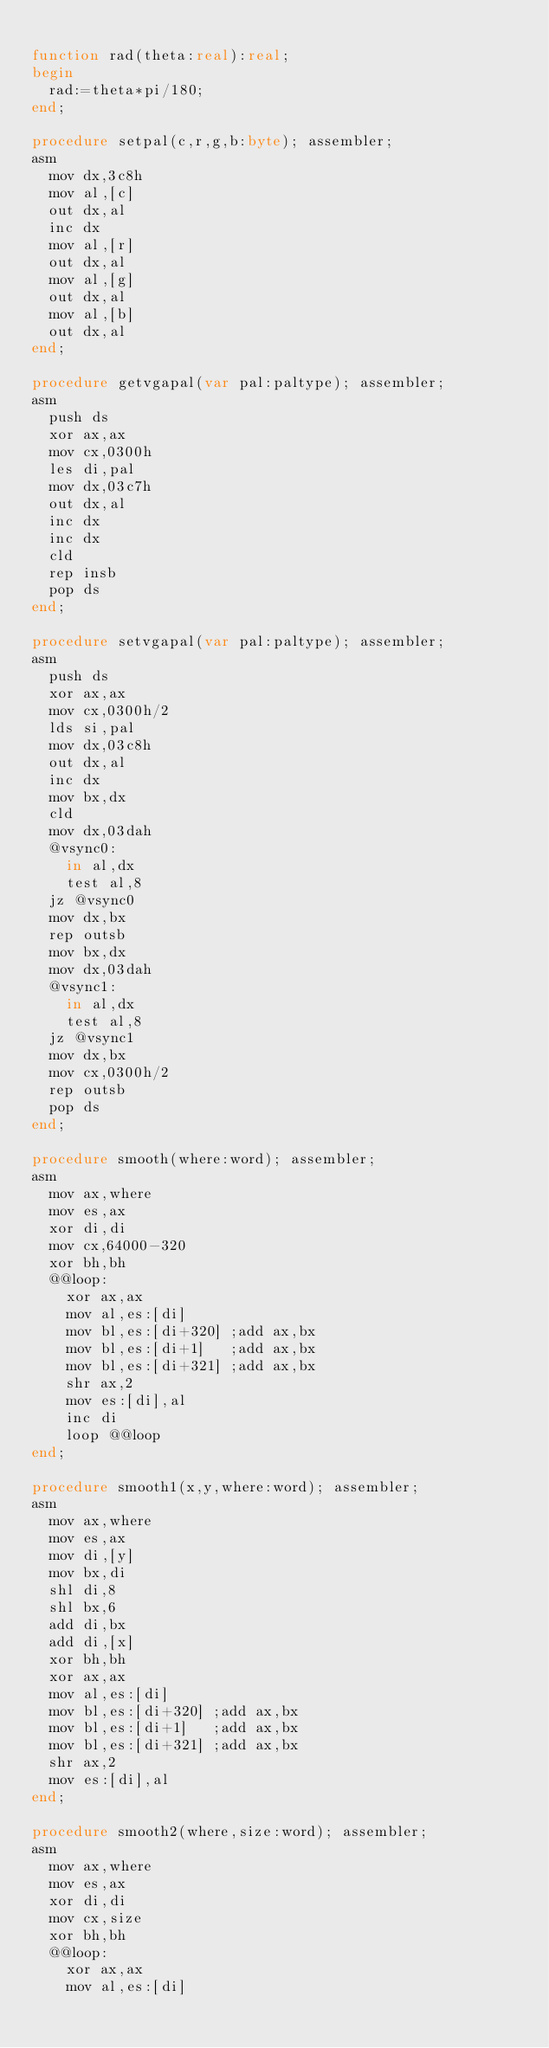Convert code to text. <code><loc_0><loc_0><loc_500><loc_500><_Pascal_>
function rad(theta:real):real;
begin
  rad:=theta*pi/180;
end;

procedure setpal(c,r,g,b:byte); assembler;
asm
  mov dx,3c8h
  mov al,[c]
  out dx,al
  inc dx
  mov al,[r]
  out dx,al
  mov al,[g]
  out dx,al
  mov al,[b]
  out dx,al
end;

procedure getvgapal(var pal:paltype); assembler;
asm
  push ds
  xor ax,ax
  mov cx,0300h
  les di,pal
  mov dx,03c7h
  out dx,al
  inc dx
  inc dx
  cld
  rep insb
  pop ds
end;

procedure setvgapal(var pal:paltype); assembler;
asm
  push ds
  xor ax,ax
  mov cx,0300h/2
  lds si,pal
  mov dx,03c8h
  out dx,al
  inc dx
  mov bx,dx
  cld
  mov dx,03dah
  @vsync0:
    in al,dx
    test al,8
  jz @vsync0
  mov dx,bx
  rep outsb
  mov bx,dx
  mov dx,03dah
  @vsync1:
    in al,dx
    test al,8
  jz @vsync1
  mov dx,bx
  mov cx,0300h/2
  rep outsb
  pop ds
end;

procedure smooth(where:word); assembler;
asm
  mov ax,where
  mov es,ax
  xor di,di
  mov cx,64000-320
  xor bh,bh
  @@loop:
    xor ax,ax
    mov al,es:[di]
    mov bl,es:[di+320] ;add ax,bx
    mov bl,es:[di+1]   ;add ax,bx
    mov bl,es:[di+321] ;add ax,bx
    shr ax,2
    mov es:[di],al
    inc di
    loop @@loop
end;

procedure smooth1(x,y,where:word); assembler;
asm
  mov ax,where
  mov es,ax
  mov di,[y]
  mov bx,di
  shl di,8
  shl bx,6
  add di,bx
  add di,[x]
  xor bh,bh
  xor ax,ax
  mov al,es:[di]
  mov bl,es:[di+320] ;add ax,bx
  mov bl,es:[di+1]   ;add ax,bx
  mov bl,es:[di+321] ;add ax,bx
  shr ax,2
  mov es:[di],al
end;

procedure smooth2(where,size:word); assembler;
asm
  mov ax,where
  mov es,ax
  xor di,di
  mov cx,size
  xor bh,bh
  @@loop:
    xor ax,ax
    mov al,es:[di]</code> 